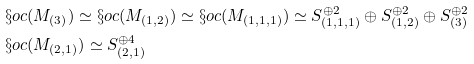Convert formula to latex. <formula><loc_0><loc_0><loc_500><loc_500>& \S o c ( M _ { ( 3 ) } ) \simeq \S o c ( M _ { ( 1 , 2 ) } ) \simeq \S o c ( M _ { ( 1 , 1 , 1 ) } ) \simeq S _ { ( 1 , 1 , 1 ) } ^ { \oplus 2 } \oplus S _ { ( 1 , 2 ) } ^ { \oplus 2 } \oplus S _ { ( 3 ) } ^ { \oplus 2 } \\ & \S o c ( M _ { ( 2 , 1 ) } ) \simeq S _ { ( 2 , 1 ) } ^ { \oplus 4 }</formula> 